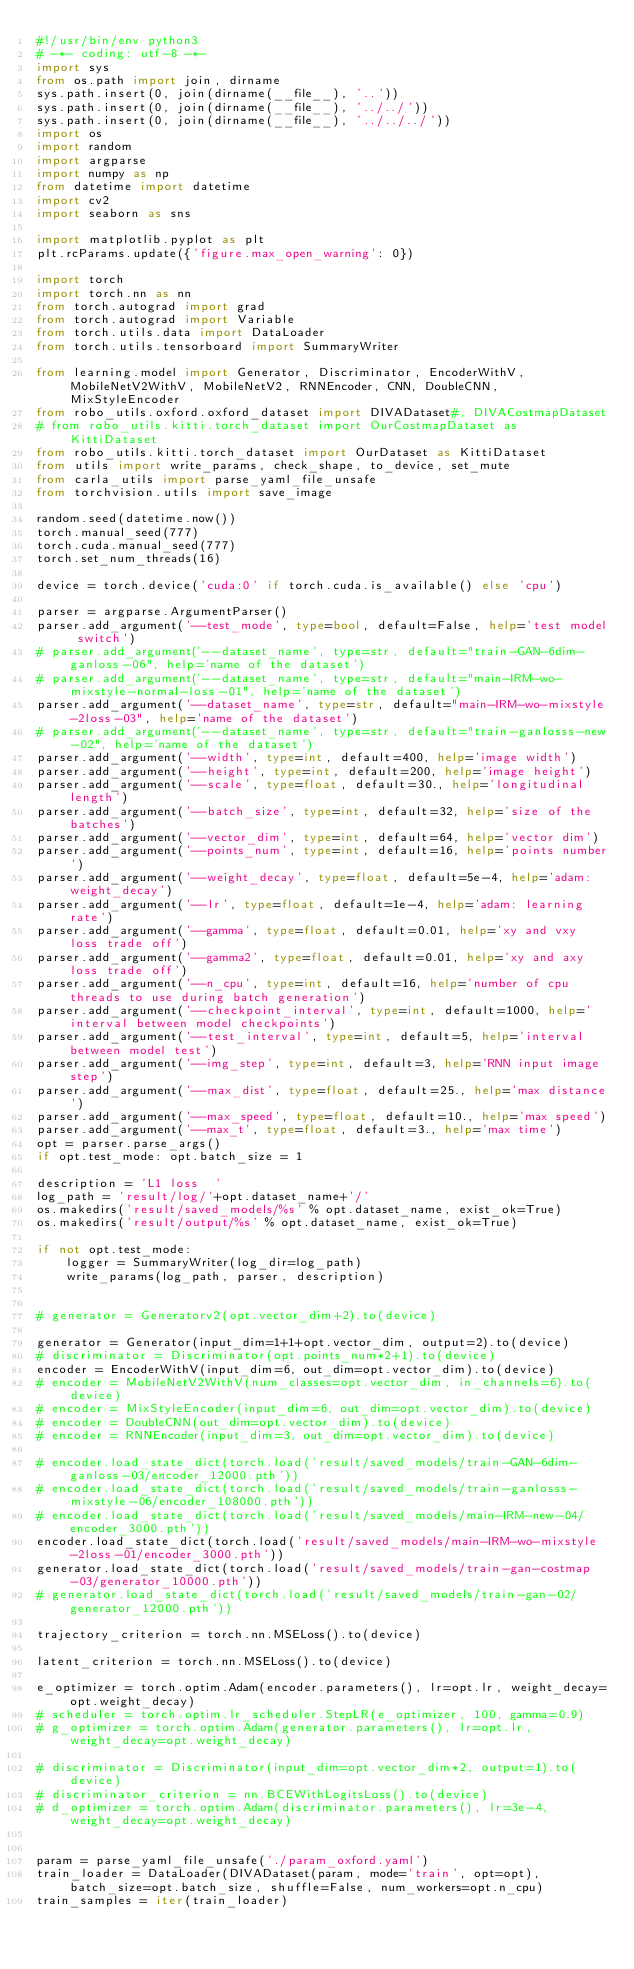<code> <loc_0><loc_0><loc_500><loc_500><_Python_>#!/usr/bin/env python3
# -*- coding: utf-8 -*-
import sys
from os.path import join, dirname
sys.path.insert(0, join(dirname(__file__), '..'))
sys.path.insert(0, join(dirname(__file__), '../../'))
sys.path.insert(0, join(dirname(__file__), '../../../'))
import os
import random
import argparse
import numpy as np
from datetime import datetime
import cv2
import seaborn as sns

import matplotlib.pyplot as plt
plt.rcParams.update({'figure.max_open_warning': 0})

import torch
import torch.nn as nn
from torch.autograd import grad
from torch.autograd import Variable
from torch.utils.data import DataLoader
from torch.utils.tensorboard import SummaryWriter

from learning.model import Generator, Discriminator, EncoderWithV, MobileNetV2WithV, MobileNetV2, RNNEncoder, CNN, DoubleCNN,MixStyleEncoder
from robo_utils.oxford.oxford_dataset import DIVADataset#, DIVACostmapDataset
# from robo_utils.kitti.torch_dataset import OurCostmapDataset as KittiDataset
from robo_utils.kitti.torch_dataset import OurDataset as KittiDataset
from utils import write_params, check_shape, to_device, set_mute
from carla_utils import parse_yaml_file_unsafe
from torchvision.utils import save_image

random.seed(datetime.now())
torch.manual_seed(777)
torch.cuda.manual_seed(777)
torch.set_num_threads(16)

device = torch.device('cuda:0' if torch.cuda.is_available() else 'cpu')

parser = argparse.ArgumentParser()
parser.add_argument('--test_mode', type=bool, default=False, help='test model switch')
# parser.add_argument('--dataset_name', type=str, default="train-GAN-6dim-ganloss-06", help='name of the dataset')
# parser.add_argument('--dataset_name', type=str, default="main-IRM-wo-mixstyle-normal-loss-01", help='name of the dataset')
parser.add_argument('--dataset_name', type=str, default="main-IRM-wo-mixstyle-2loss-03", help='name of the dataset')
# parser.add_argument('--dataset_name', type=str, default="train-ganlosss-new-02", help='name of the dataset')
parser.add_argument('--width', type=int, default=400, help='image width')
parser.add_argument('--height', type=int, default=200, help='image height')
parser.add_argument('--scale', type=float, default=30., help='longitudinal length')
parser.add_argument('--batch_size', type=int, default=32, help='size of the batches')
parser.add_argument('--vector_dim', type=int, default=64, help='vector dim')
parser.add_argument('--points_num', type=int, default=16, help='points number')
parser.add_argument('--weight_decay', type=float, default=5e-4, help='adam: weight_decay')
parser.add_argument('--lr', type=float, default=1e-4, help='adam: learning rate')
parser.add_argument('--gamma', type=float, default=0.01, help='xy and vxy loss trade off')
parser.add_argument('--gamma2', type=float, default=0.01, help='xy and axy loss trade off')
parser.add_argument('--n_cpu', type=int, default=16, help='number of cpu threads to use during batch generation')
parser.add_argument('--checkpoint_interval', type=int, default=1000, help='interval between model checkpoints')
parser.add_argument('--test_interval', type=int, default=5, help='interval between model test')
parser.add_argument('--img_step', type=int, default=3, help='RNN input image step')
parser.add_argument('--max_dist', type=float, default=25., help='max distance')
parser.add_argument('--max_speed', type=float, default=10., help='max speed')
parser.add_argument('--max_t', type=float, default=3., help='max time')
opt = parser.parse_args()
if opt.test_mode: opt.batch_size = 1
    
description = 'L1 loss  '
log_path = 'result/log/'+opt.dataset_name+'/'
os.makedirs('result/saved_models/%s' % opt.dataset_name, exist_ok=True)
os.makedirs('result/output/%s' % opt.dataset_name, exist_ok=True)

if not opt.test_mode:
    logger = SummaryWriter(log_dir=log_path)
    write_params(log_path, parser, description)


# generator = Generatorv2(opt.vector_dim+2).to(device)

generator = Generator(input_dim=1+1+opt.vector_dim, output=2).to(device)
# discriminator = Discriminator(opt.points_num*2+1).to(device)
encoder = EncoderWithV(input_dim=6, out_dim=opt.vector_dim).to(device)
# encoder = MobileNetV2WithV(num_classes=opt.vector_dim, in_channels=6).to(device)
# encoder = MixStyleEncoder(input_dim=6, out_dim=opt.vector_dim).to(device)
# encoder = DoubleCNN(out_dim=opt.vector_dim).to(device)
# encoder = RNNEncoder(input_dim=3, out_dim=opt.vector_dim).to(device)

# encoder.load_state_dict(torch.load('result/saved_models/train-GAN-6dim-ganloss-03/encoder_12000.pth'))
# encoder.load_state_dict(torch.load('result/saved_models/train-ganlosss-mixstyle-06/encoder_108000.pth'))
# encoder.load_state_dict(torch.load('result/saved_models/main-IRM-new-04/encoder_3000.pth'))
encoder.load_state_dict(torch.load('result/saved_models/main-IRM-wo-mixstyle-2loss-01/encoder_3000.pth'))
generator.load_state_dict(torch.load('result/saved_models/train-gan-costmap-03/generator_10000.pth'))
# generator.load_state_dict(torch.load('result/saved_models/train-gan-02/generator_12000.pth'))

trajectory_criterion = torch.nn.MSELoss().to(device)

latent_criterion = torch.nn.MSELoss().to(device)

e_optimizer = torch.optim.Adam(encoder.parameters(), lr=opt.lr, weight_decay=opt.weight_decay)
# scheduler = torch.optim.lr_scheduler.StepLR(e_optimizer, 100, gamma=0.9)
# g_optimizer = torch.optim.Adam(generator.parameters(), lr=opt.lr, weight_decay=opt.weight_decay)

# discriminator = Discriminator(input_dim=opt.vector_dim*2, output=1).to(device)
# discriminator_criterion = nn.BCEWithLogitsLoss().to(device)
# d_optimizer = torch.optim.Adam(discriminator.parameters(), lr=3e-4, weight_decay=opt.weight_decay)


param = parse_yaml_file_unsafe('./param_oxford.yaml')
train_loader = DataLoader(DIVADataset(param, mode='train', opt=opt), batch_size=opt.batch_size, shuffle=False, num_workers=opt.n_cpu)
train_samples = iter(train_loader)
</code> 